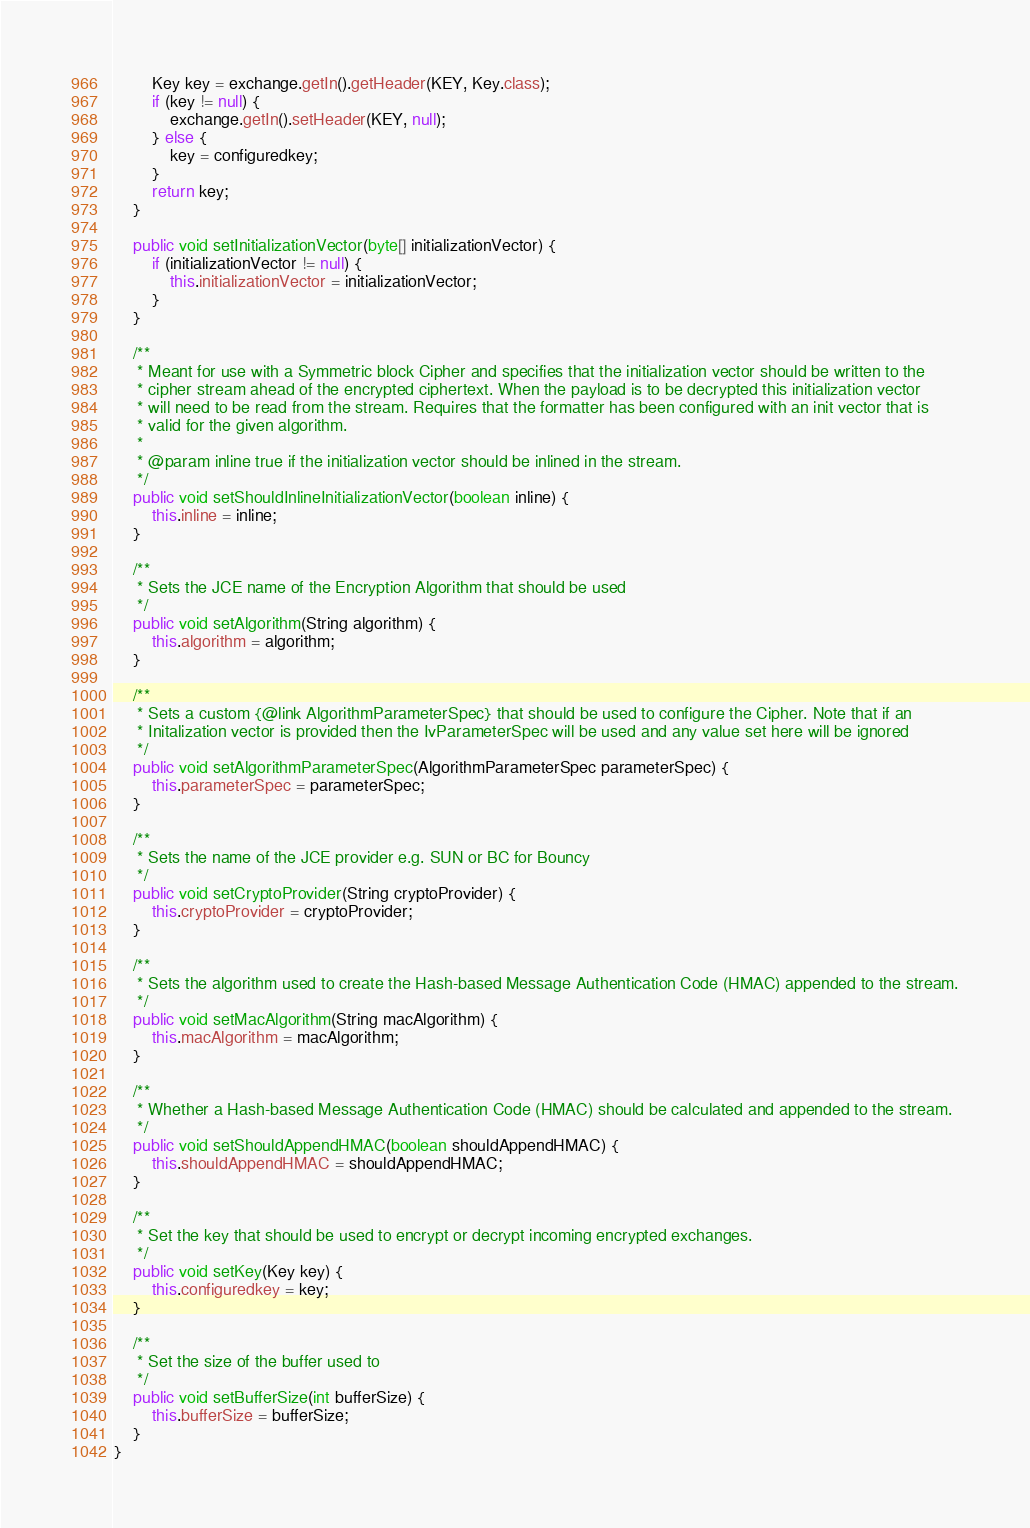Convert code to text. <code><loc_0><loc_0><loc_500><loc_500><_Java_>        Key key = exchange.getIn().getHeader(KEY, Key.class);
        if (key != null) {
            exchange.getIn().setHeader(KEY, null);
        } else {
            key = configuredkey;
        }
        return key;
    }

    public void setInitializationVector(byte[] initializationVector) {
        if (initializationVector != null) {
            this.initializationVector = initializationVector;
        }
    }

    /**
     * Meant for use with a Symmetric block Cipher and specifies that the initialization vector should be written to the
     * cipher stream ahead of the encrypted ciphertext. When the payload is to be decrypted this initialization vector
     * will need to be read from the stream. Requires that the formatter has been configured with an init vector that is
     * valid for the given algorithm.
     *
     * @param inline true if the initialization vector should be inlined in the stream.
     */
    public void setShouldInlineInitializationVector(boolean inline) {
        this.inline = inline;
    }

    /**
     * Sets the JCE name of the Encryption Algorithm that should be used
     */
    public void setAlgorithm(String algorithm) {
        this.algorithm = algorithm;
    }

    /**
     * Sets a custom {@link AlgorithmParameterSpec} that should be used to configure the Cipher. Note that if an
     * Initalization vector is provided then the IvParameterSpec will be used and any value set here will be ignored
     */
    public void setAlgorithmParameterSpec(AlgorithmParameterSpec parameterSpec) {
        this.parameterSpec = parameterSpec;
    }

    /**
     * Sets the name of the JCE provider e.g. SUN or BC for Bouncy
     */
    public void setCryptoProvider(String cryptoProvider) {
        this.cryptoProvider = cryptoProvider;
    }

    /**
     * Sets the algorithm used to create the Hash-based Message Authentication Code (HMAC) appended to the stream.
     */
    public void setMacAlgorithm(String macAlgorithm) {
        this.macAlgorithm = macAlgorithm;
    }

    /**
     * Whether a Hash-based Message Authentication Code (HMAC) should be calculated and appended to the stream.
     */
    public void setShouldAppendHMAC(boolean shouldAppendHMAC) {
        this.shouldAppendHMAC = shouldAppendHMAC;
    }

    /**
     * Set the key that should be used to encrypt or decrypt incoming encrypted exchanges.
     */
    public void setKey(Key key) {
        this.configuredkey = key;
    }

    /**
     * Set the size of the buffer used to
     */
    public void setBufferSize(int bufferSize) {
        this.bufferSize = bufferSize;
    }
}
</code> 